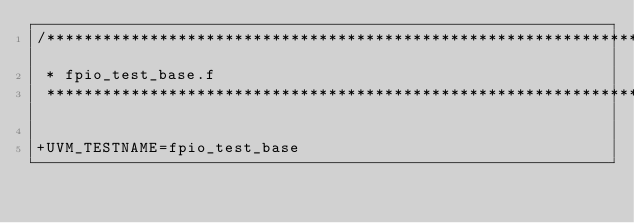<code> <loc_0><loc_0><loc_500><loc_500><_FORTRAN_>/*****************************************************************************
 * fpio_test_base.f
 *****************************************************************************/
 
+UVM_TESTNAME=fpio_test_base

</code> 